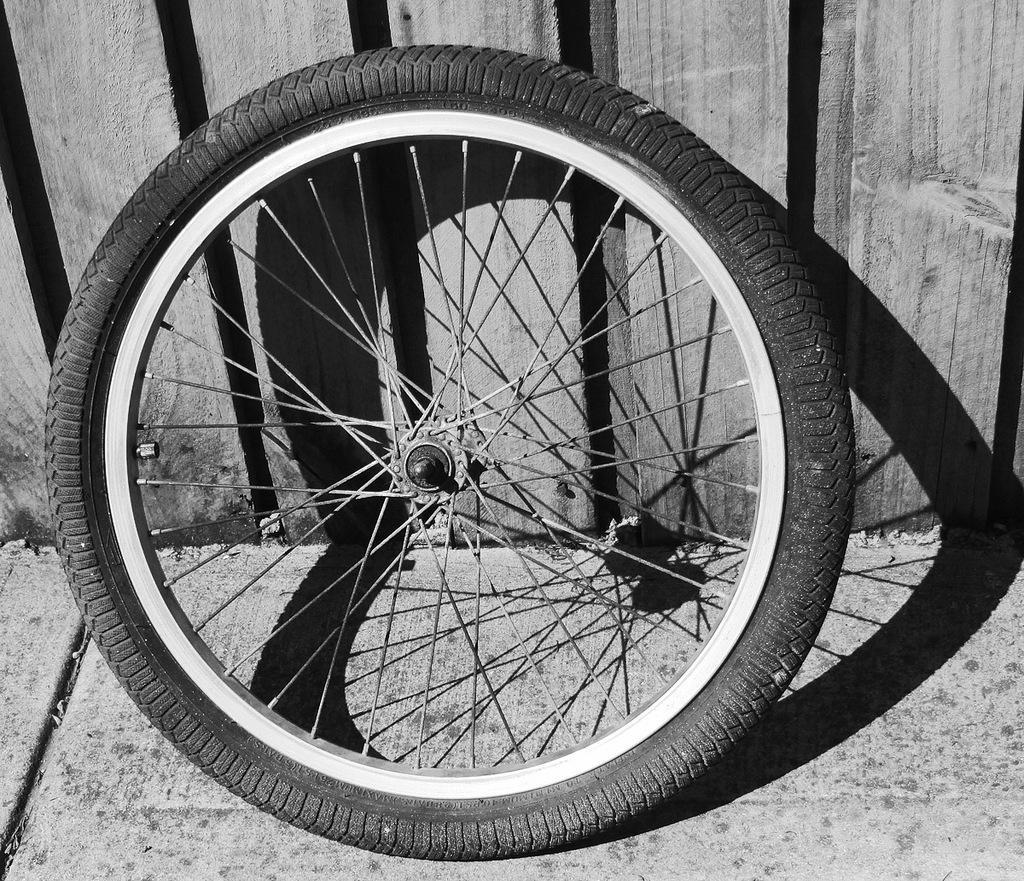Could you give a brief overview of what you see in this image? In this picture I can see there is a wheel and it has spokes, tire, rim and there is a wooden wall in the backdrop. 